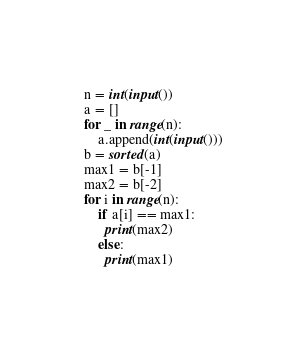<code> <loc_0><loc_0><loc_500><loc_500><_Python_>n = int(input())
a = []
for _ in range(n):
    a.append(int(input()))
b = sorted(a)
max1 = b[-1]
max2 = b[-2]
for i in range(n):
    if a[i] == max1:
      print(max2)
    else:
      print(max1)</code> 